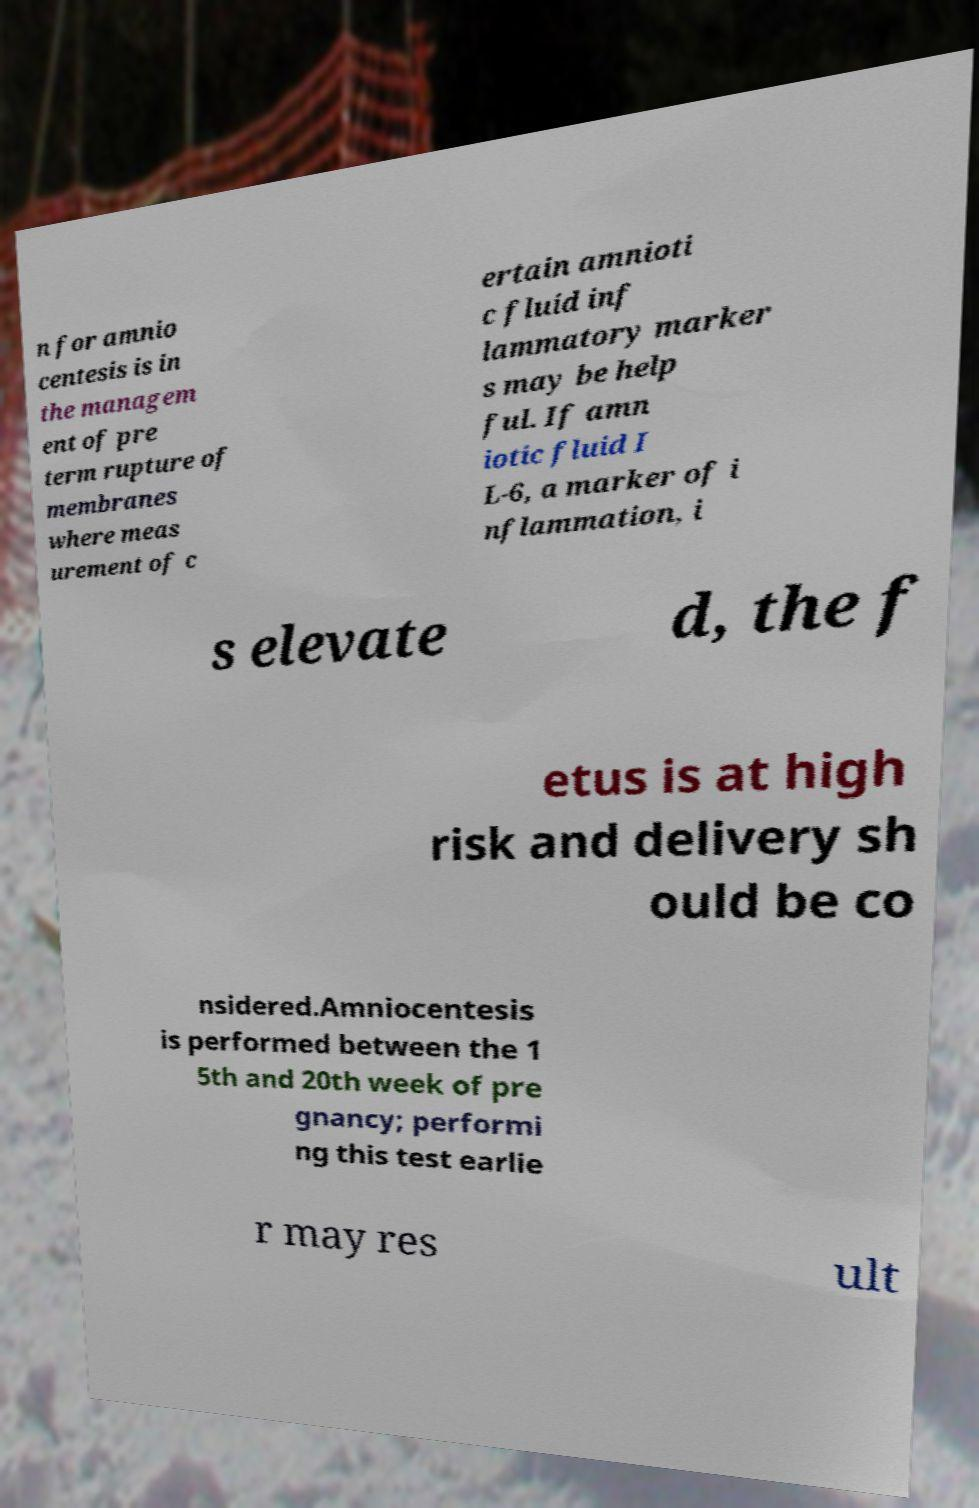There's text embedded in this image that I need extracted. Can you transcribe it verbatim? n for amnio centesis is in the managem ent of pre term rupture of membranes where meas urement of c ertain amnioti c fluid inf lammatory marker s may be help ful. If amn iotic fluid I L-6, a marker of i nflammation, i s elevate d, the f etus is at high risk and delivery sh ould be co nsidered.Amniocentesis is performed between the 1 5th and 20th week of pre gnancy; performi ng this test earlie r may res ult 